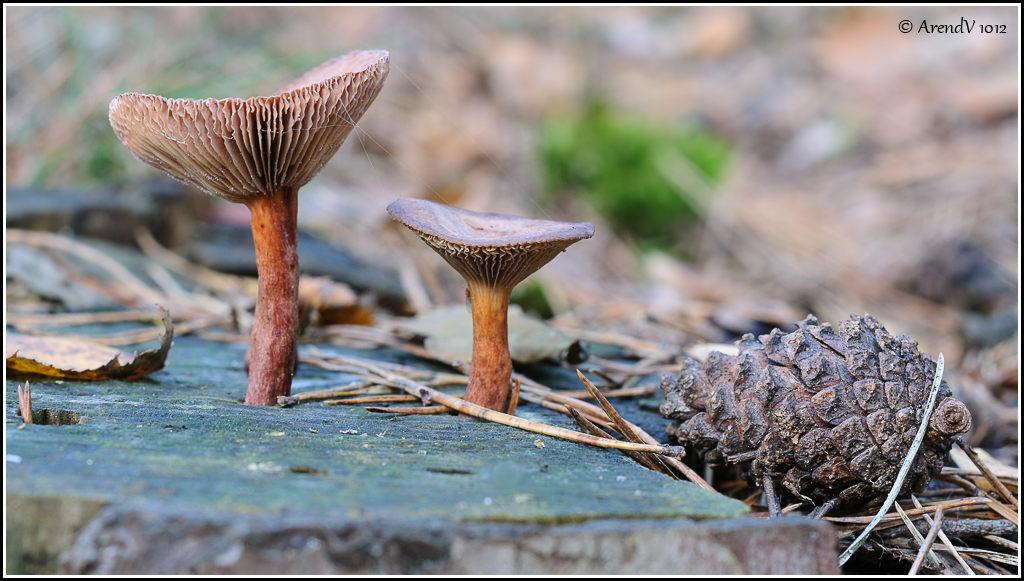What type of fungi can be seen in the image? There are mushrooms in the image. What other natural objects are present in the image? There are dried sticks and plants visible in the image. Can you describe the fruit in the image? There is a dried pineapple fruit in the image. How would you describe the background of the image? The background of the image is blurred. Is there any text present in the image? Yes, there is some text at the top of the image. What type of crime is being committed in the image? There is no crime present in the image; it features mushrooms, dried sticks, plants, a dried pineapple fruit, a blurred background, and some text. What type of hat is worn by the mushroom in the image? There are no hats present in the image, as it features mushrooms, dried sticks, plants, a dried pineapple fruit, a blurred background, and some text. 